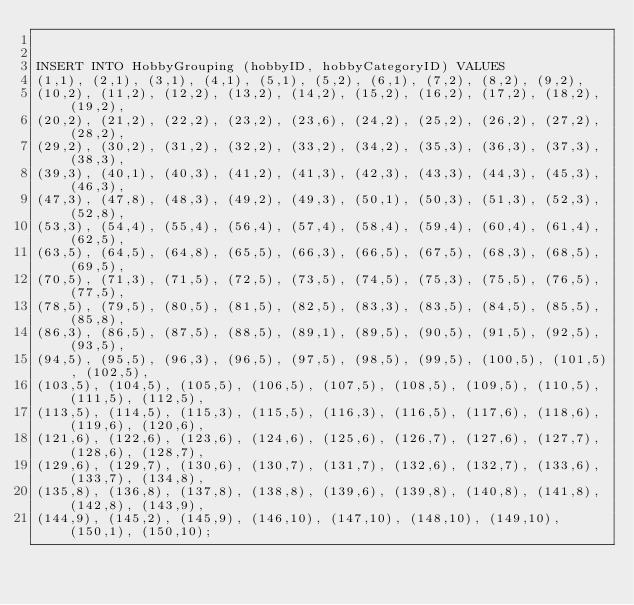<code> <loc_0><loc_0><loc_500><loc_500><_SQL_>

INSERT INTO HobbyGrouping (hobbyID, hobbyCategoryID) VALUES
(1,1), (2,1), (3,1), (4,1), (5,1), (5,2), (6,1), (7,2), (8,2), (9,2), 
(10,2), (11,2), (12,2), (13,2), (14,2), (15,2), (16,2), (17,2), (18,2), (19,2), 
(20,2), (21,2), (22,2), (23,2), (23,6), (24,2), (25,2), (26,2), (27,2), (28,2), 
(29,2), (30,2), (31,2), (32,2), (33,2), (34,2), (35,3), (36,3), (37,3), (38,3), 
(39,3), (40,1), (40,3), (41,2), (41,3), (42,3), (43,3), (44,3), (45,3), (46,3), 
(47,3), (47,8), (48,3), (49,2), (49,3), (50,1), (50,3), (51,3), (52,3), (52,8), 
(53,3), (54,4), (55,4), (56,4), (57,4), (58,4), (59,4), (60,4), (61,4), (62,5), 
(63,5), (64,5), (64,8), (65,5), (66,3), (66,5), (67,5), (68,3), (68,5), (69,5), 
(70,5), (71,3), (71,5), (72,5), (73,5), (74,5), (75,3), (75,5), (76,5), (77,5), 
(78,5), (79,5), (80,5), (81,5), (82,5), (83,3), (83,5), (84,5), (85,5), (85,8), 
(86,3), (86,5), (87,5), (88,5), (89,1), (89,5), (90,5), (91,5), (92,5), (93,5), 
(94,5), (95,5), (96,3), (96,5), (97,5), (98,5), (99,5), (100,5), (101,5), (102,5), 
(103,5), (104,5), (105,5), (106,5), (107,5), (108,5), (109,5), (110,5), (111,5), (112,5), 
(113,5), (114,5), (115,3), (115,5), (116,3), (116,5), (117,6), (118,6), (119,6), (120,6), 
(121,6), (122,6), (123,6), (124,6), (125,6), (126,7), (127,6), (127,7), (128,6), (128,7), 
(129,6), (129,7), (130,6), (130,7), (131,7), (132,6), (132,7), (133,6), (133,7), (134,8), 
(135,8), (136,8), (137,8), (138,8), (139,6), (139,8), (140,8), (141,8), (142,8), (143,9), 
(144,9), (145,2), (145,9), (146,10), (147,10), (148,10), (149,10), (150,1), (150,10);</code> 